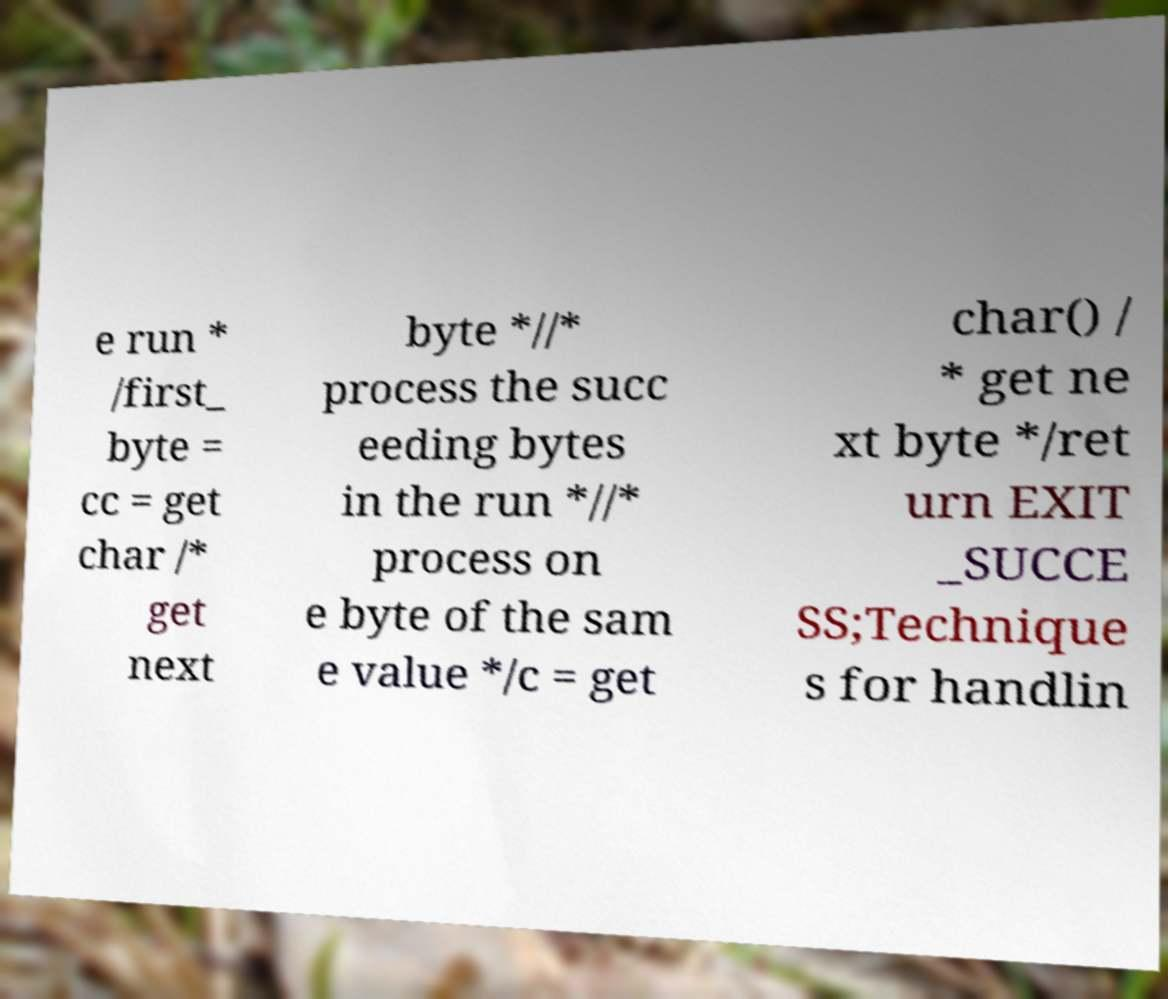Can you read and provide the text displayed in the image?This photo seems to have some interesting text. Can you extract and type it out for me? e run * /first_ byte = cc = get char /* get next byte *//* process the succ eeding bytes in the run *//* process on e byte of the sam e value */c = get char() / * get ne xt byte */ret urn EXIT _SUCCE SS;Technique s for handlin 